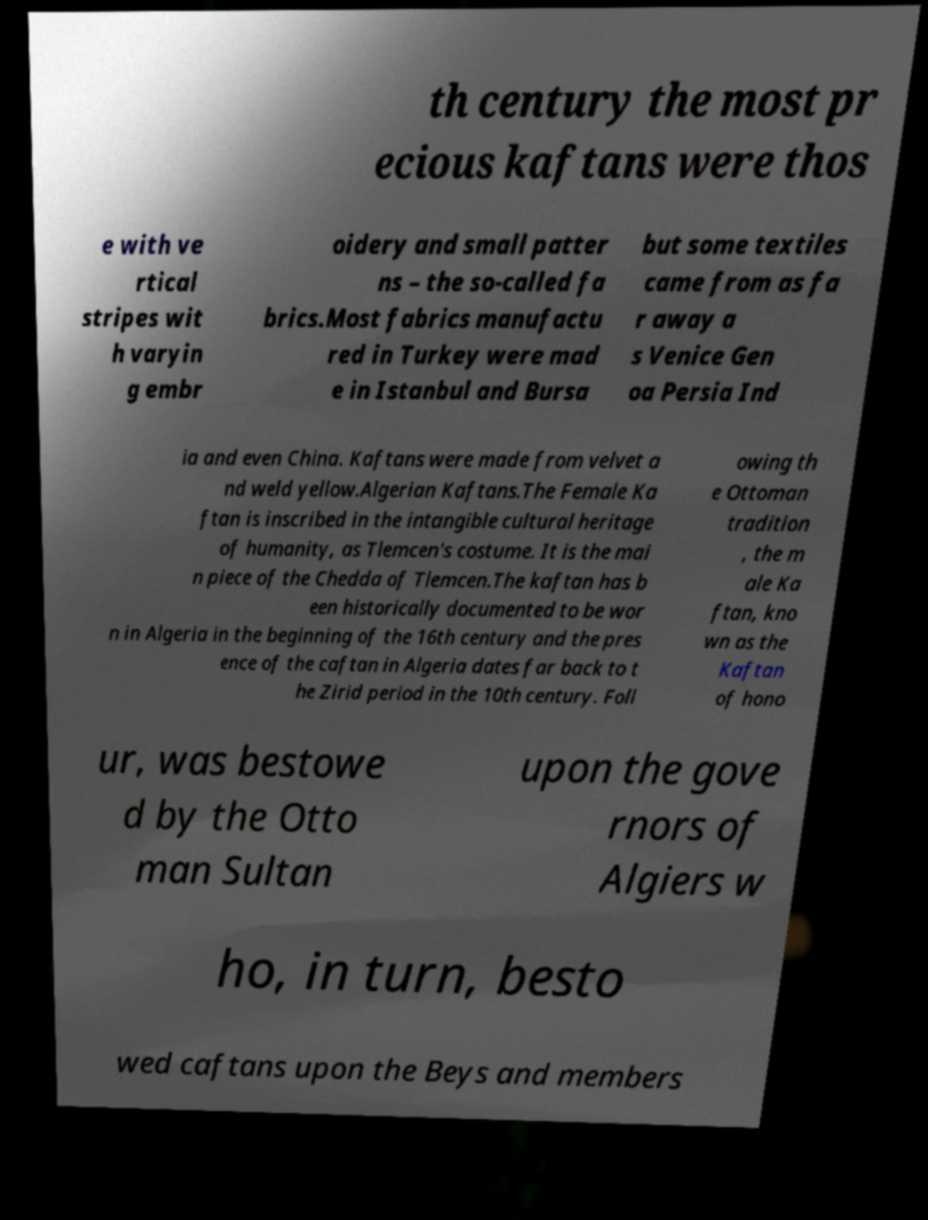Please read and relay the text visible in this image. What does it say? th century the most pr ecious kaftans were thos e with ve rtical stripes wit h varyin g embr oidery and small patter ns – the so-called fa brics.Most fabrics manufactu red in Turkey were mad e in Istanbul and Bursa but some textiles came from as fa r away a s Venice Gen oa Persia Ind ia and even China. Kaftans were made from velvet a nd weld yellow.Algerian Kaftans.The Female Ka ftan is inscribed in the intangible cultural heritage of humanity, as Tlemcen's costume. It is the mai n piece of the Chedda of Tlemcen.The kaftan has b een historically documented to be wor n in Algeria in the beginning of the 16th century and the pres ence of the caftan in Algeria dates far back to t he Zirid period in the 10th century. Foll owing th e Ottoman tradition , the m ale Ka ftan, kno wn as the Kaftan of hono ur, was bestowe d by the Otto man Sultan upon the gove rnors of Algiers w ho, in turn, besto wed caftans upon the Beys and members 